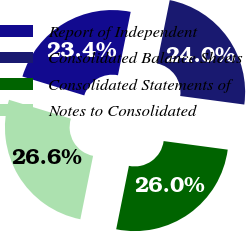<chart> <loc_0><loc_0><loc_500><loc_500><pie_chart><fcel>Report of Independent<fcel>Consolidated Balance Sheets<fcel>Consolidated Statements of<fcel>Notes to Consolidated<nl><fcel>23.44%<fcel>23.96%<fcel>26.04%<fcel>26.56%<nl></chart> 